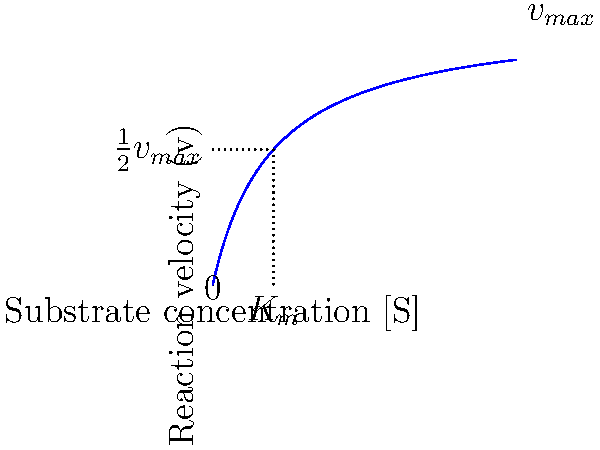In the Michaelis-Menten kinetics model shown in the graph, what does the $K_m$ value represent, and how does it relate to enzyme-substrate affinity in the context of developing a new biotechnology therapy? To understand the significance of $K_m$ in enzyme kinetics and its relevance to biotechnology therapy development:

1. $K_m$ definition: The Michaelis constant, $K_m$, is the substrate concentration at which the reaction velocity is half of the maximum velocity ($\frac{1}{2}v_{max}$).

2. Graphical representation: In the plot, $K_m$ is shown on the x-axis, corresponding to the [S] value where v = $\frac{1}{2}v_{max}$.

3. Enzyme-substrate affinity: $K_m$ is inversely related to the enzyme's affinity for the substrate. A lower $K_m$ indicates higher affinity, as the enzyme reaches half its maximum velocity at a lower substrate concentration.

4. Biotechnology applications: In therapy development, understanding $K_m$ is crucial for:
   a. Optimizing drug dosages: Lower $K_m$ may allow for lower drug concentrations.
   b. Designing enzyme inhibitors or activators: Targeting enzymes with specific $K_m$ values.
   c. Enzyme engineering: Modifying enzymes to alter their $K_m$ for improved therapeutic efficacy.

5. Therapeutic implications: A lower $K_m$ might lead to more efficient therapies, potentially reducing side effects and improving patient outcomes.

6. Competitive advantage: Developing enzymes or drugs with optimized $K_m$ values could provide a significant edge in the biotechnology market.
Answer: $K_m$ represents the substrate concentration at half-maximum reaction velocity, inversely indicating enzyme-substrate affinity. Lower $K_m$ suggests higher affinity, crucial for optimizing therapeutic efficacy and dosing in biotechnology applications. 